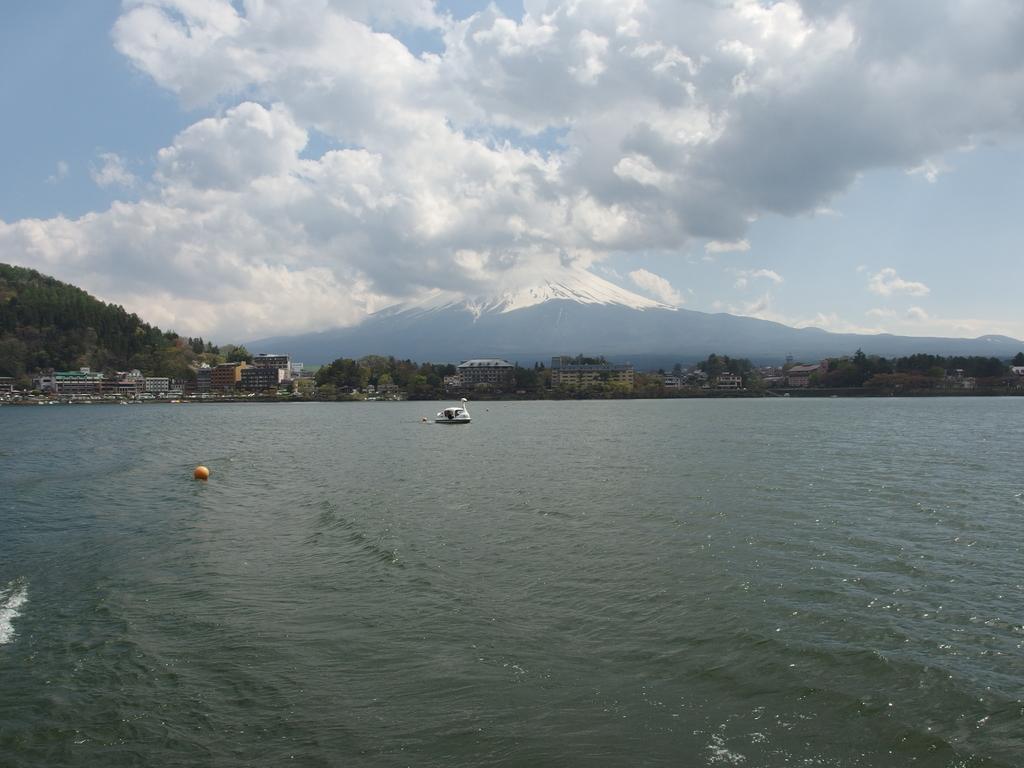Could you give a brief overview of what you see in this image? In this image, we can see the water, there is a boat on the water, we can see some buildings and there are some trees, we can see a mountain, at the top there is a sky and we can see the clouds. 